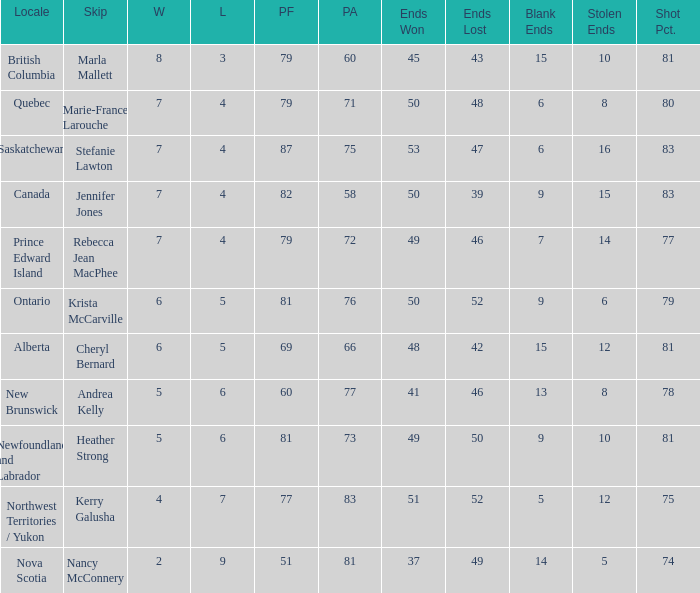What is the power factor for rebecca jean macphee? 79.0. 